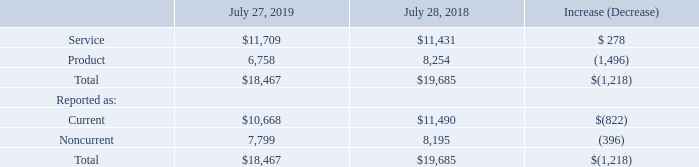Deferred Revenue The following table presents the breakdown of deferred revenue (in millions):
Deferred revenue decreased primarily due to the adoption of ASC 606 in the beginning of our first quarter of fiscal 2019. Of the total deferred revenue decrease related to the adoption of ASC 606 of $2.8 billion, $2.6 billion relates to deferred product revenue and $0.2 billion relates to deferred service revenue. Of the adjustment to deferred product revenue, $1.3 billion related to our recurring software and subscription offers, $0.6 billion related to two-tier distribution, and the remainder related to nonrecurring software and other adjustments. The decrease related to the adoption of ASC 606 was partially offset by an increase in product deferred revenue during the fiscal year. The increase in deferred service revenue was driven by the impact of contract renewals, partially offset by amortization of deferred service revenue.
What was the main reason for the decrease in revenue? Due to the adoption of asc 606 in the beginning of our first quarter of fiscal 2019. Why did deferred service revenue increase? Driven by the impact of contract renewals, partially offset by amortization of deferred service revenue. Which years does the table provide information for the breakdown of the company's deferred revenue? 2019, 2018. What was the percentage change in service revenue between 2018 and 2019?
Answer scale should be: percent. (11,709-11,431)/11,431
Answer: 2.43. How many years did total reported deferred revenue exceed $15,000 million? 2019##2018
Answer: 2. What was the percentage change in the total product revenue between 2018 and 2019?
Answer scale should be: percent. (6,758-8,254)/8,254
Answer: -18.12. 